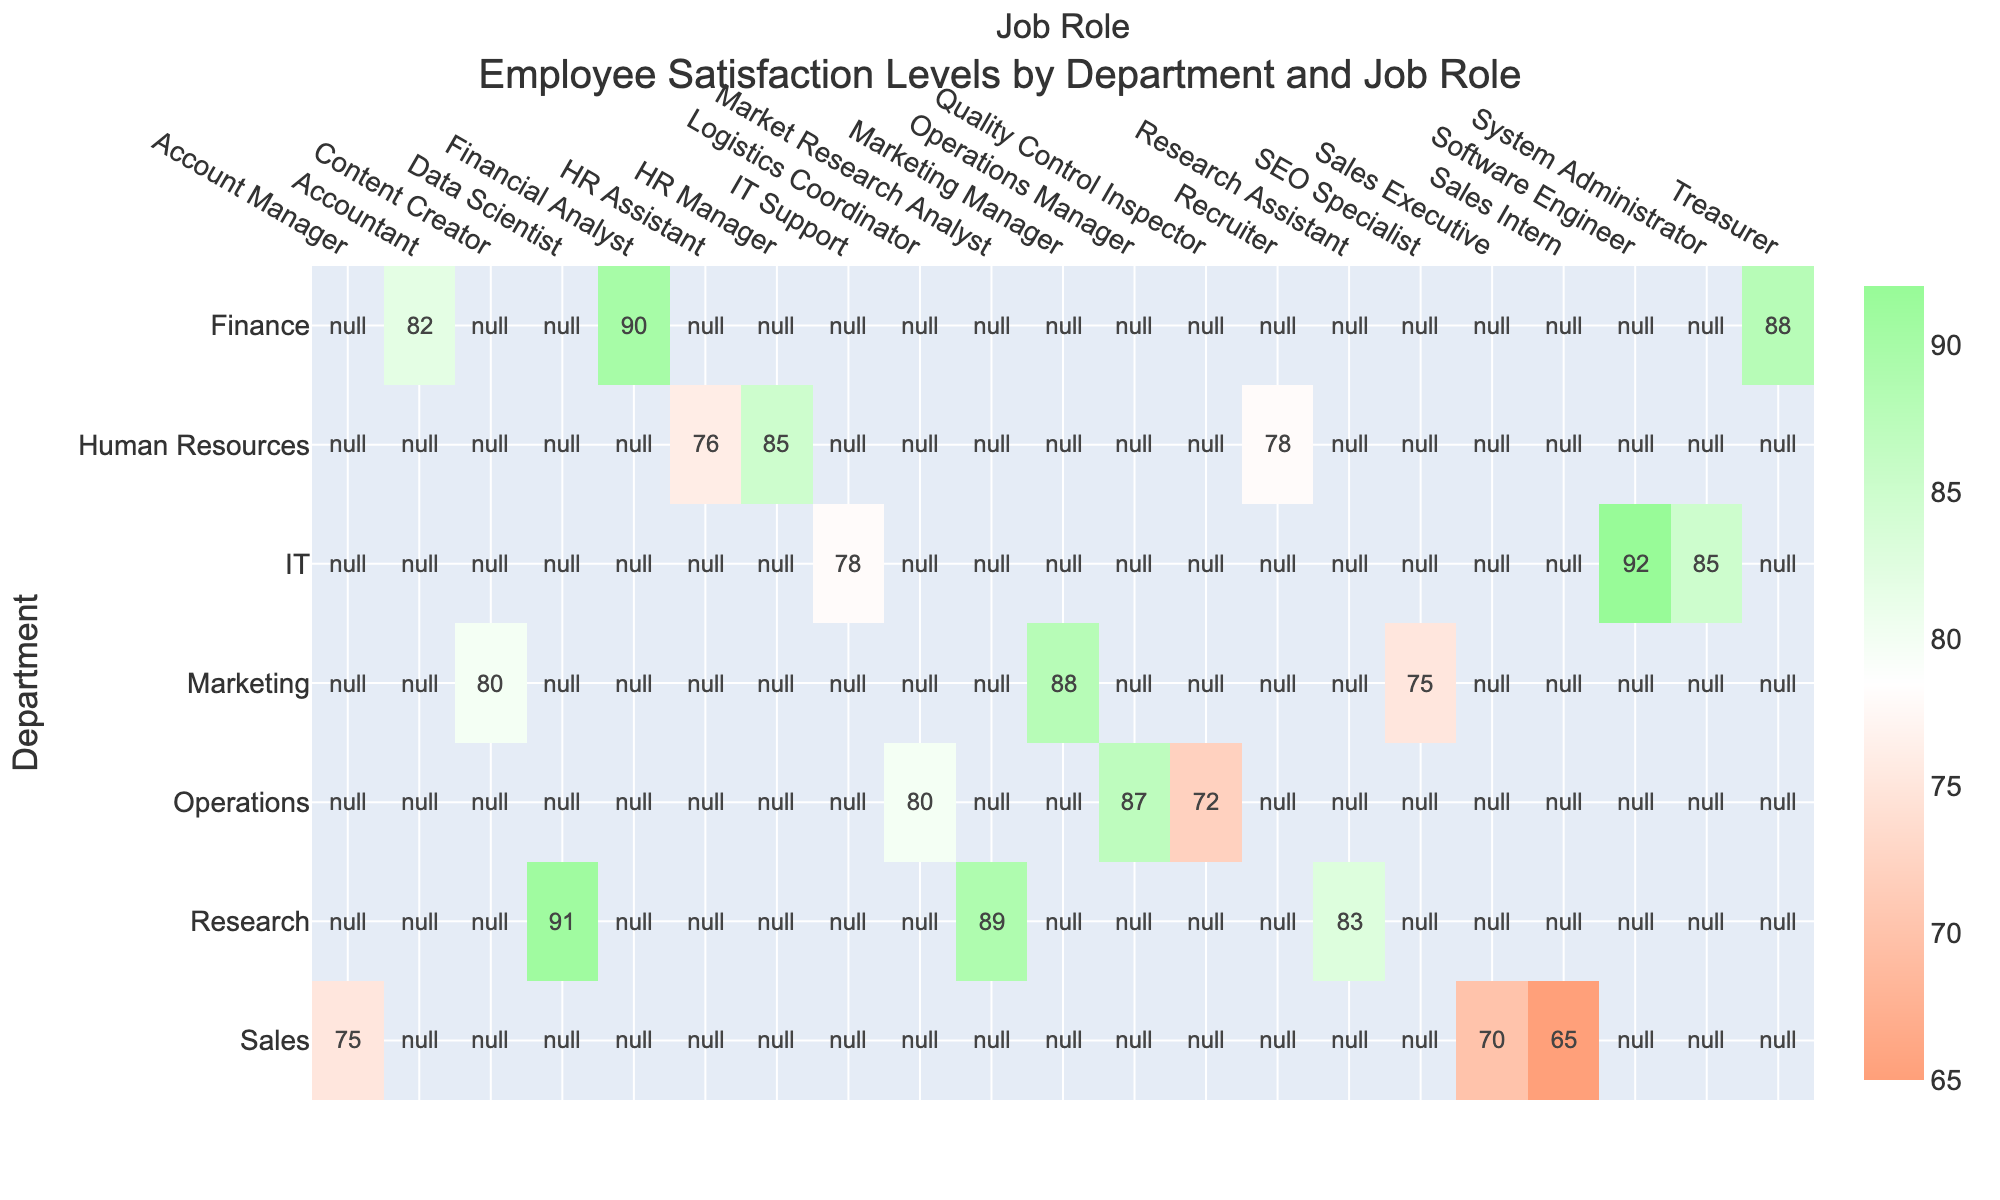What is the satisfaction level of the HR Manager? The HR Manager's satisfaction level is clearly listed under the Human Resources department in the table, which shows a value of 85.
Answer: 85 Which job role in the Finance department has the highest satisfaction level? In the Finance department, the satisfaction levels of the job roles are: Financial Analyst (90), Accountant (82), and Treasurer (88). The Financial Analyst has the highest value at 90.
Answer: Financial Analyst What is the average satisfaction level for job roles in the Sales department? The satisfaction levels for Sales department roles are: Sales Executive (70), Account Manager (75), and Sales Intern (65). Adding these gives us 70 + 75 + 65 = 210. Dividing by the number of roles (3) results in an average satisfaction level of 210 / 3 = 70.
Answer: 70 Is the satisfaction level of the IT Support role higher than the Research Assistant role? The satisfaction level for IT Support is 78, while for the Research Assistant, it is 83. Since 78 is less than 83, the statement is false.
Answer: No Which department has the highest average satisfaction level? To find the average satisfaction for each department: Human Resources (76.3), Finance (86.7), Sales (70), Marketing (81.0), IT (85.0), Operations (79.7), and Research (88.3). The highest average is for the Finance department at 86.7.
Answer: Finance What are the satisfaction levels for job roles in the Marketing department? The Marketing department has the following satisfaction levels: Marketing Manager (88), Content Creator (80), and SEO Specialist (75).
Answer: 88, 80, 75 Is there a job role in the Operations department with a satisfaction level of less than 75? The job roles in Operations are: Operations Manager (87), Logistics Coordinator (80), and Quality Control Inspector (72). Since the Quality Control Inspector has a satisfaction level of 72, which is less than 75, the answer is yes.
Answer: Yes What is the satisfaction level of the Data Scientist compared to the Financial Analyst? The Data Scientist has a satisfaction level of 91, while the Financial Analyst has a satisfaction level of 90. Comparing these two, the Data Scientist has a higher satisfaction level.
Answer: Yes 